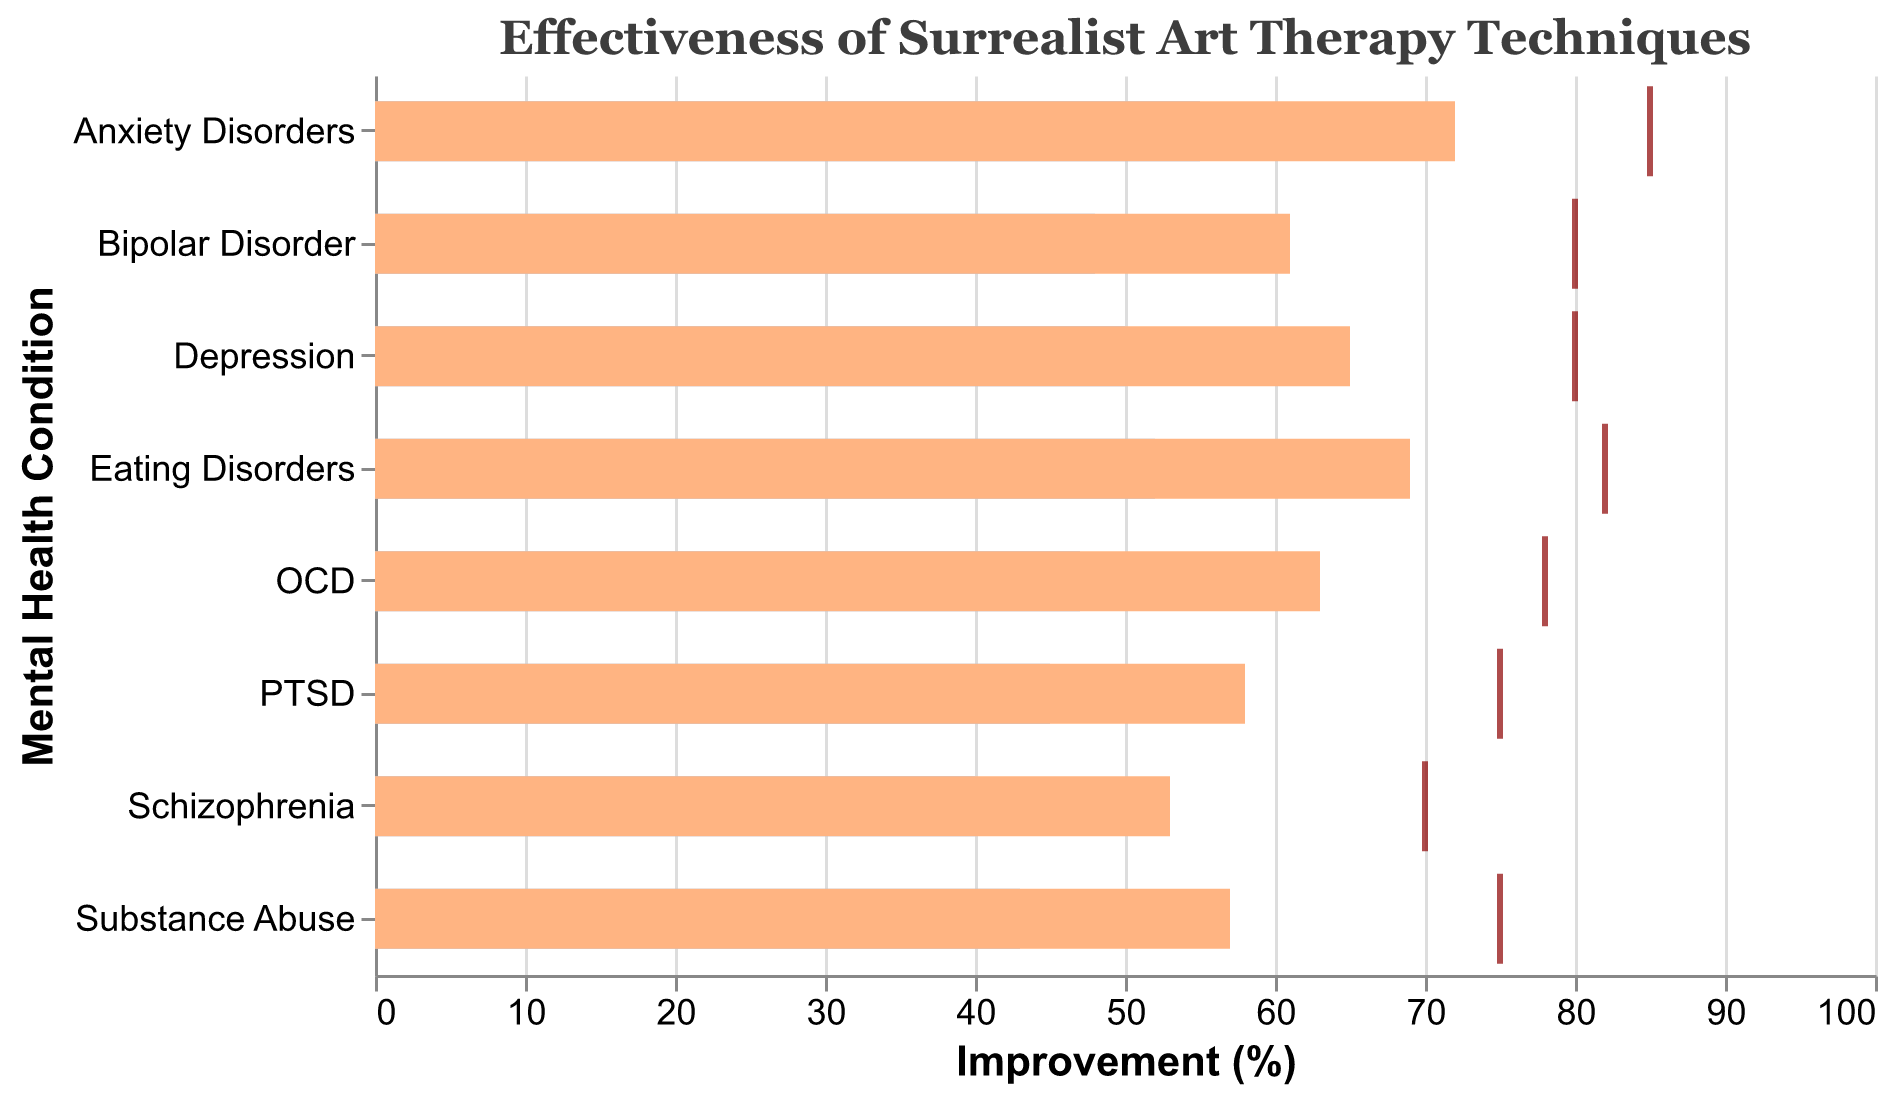What is the title of the chart? The title is displayed at the top of the chart and provides a brief description of the data being shown.
Answer: Effectiveness of Surrealist Art Therapy Techniques How many mental health conditions are represented in the chart? By counting the number of bars (each corresponding to a mental health condition) present on the y-axis of the chart.
Answer: 8 Which mental health condition has the highest actual improvement percentage? By examining the lengths of the bars representing actual improvement, the longest bar indicates the highest improvement.
Answer: Anxiety Disorders Which condition shows the largest gap between actual and target improvement? To find the largest gap, subtract the actual improvement from the target improvement for each condition and identify the one with the highest value. The condition with the largest gap is the one with the greatest difference between these two values.
Answer: Anxiety Disorders What is the actual improvement percentage for PTSD? Find the bar that corresponds to PTSD and read the value associated with the actual improvement.
Answer: 58% Which condition has the lowest benchmark improvement? By looking at the shortest bar representing the benchmark value, the condition with the shortest bar has the lowest benchmark improvement.
Answer: Schizophrenia Compare the actual improvement percentages of Bipolar Disorder and OCD. Which is higher? Locate the bars for Bipolar Disorder and OCD, and then compare their lengths to determine which one is higher.
Answer: Bipolar Disorder How does the actual improvement for Substance Abuse compare to its benchmark improvement? Compare the length of the bar representing actual improvement for Substance Abuse with the bar representing its benchmark improvement.
Answer: Higher What is the difference between the target and actual improvement for Eating Disorders? Subtract the actual improvement percentage for Eating Disorders from the target improvement percentage given for Eating Disorders.
Answer: 13% What are the colors used to show benchmark and actual improvements? Identify the colors used in the bars representing benchmark and actual improvements.
Answer: Light blue (benchmark), light orange (actual improvement) 